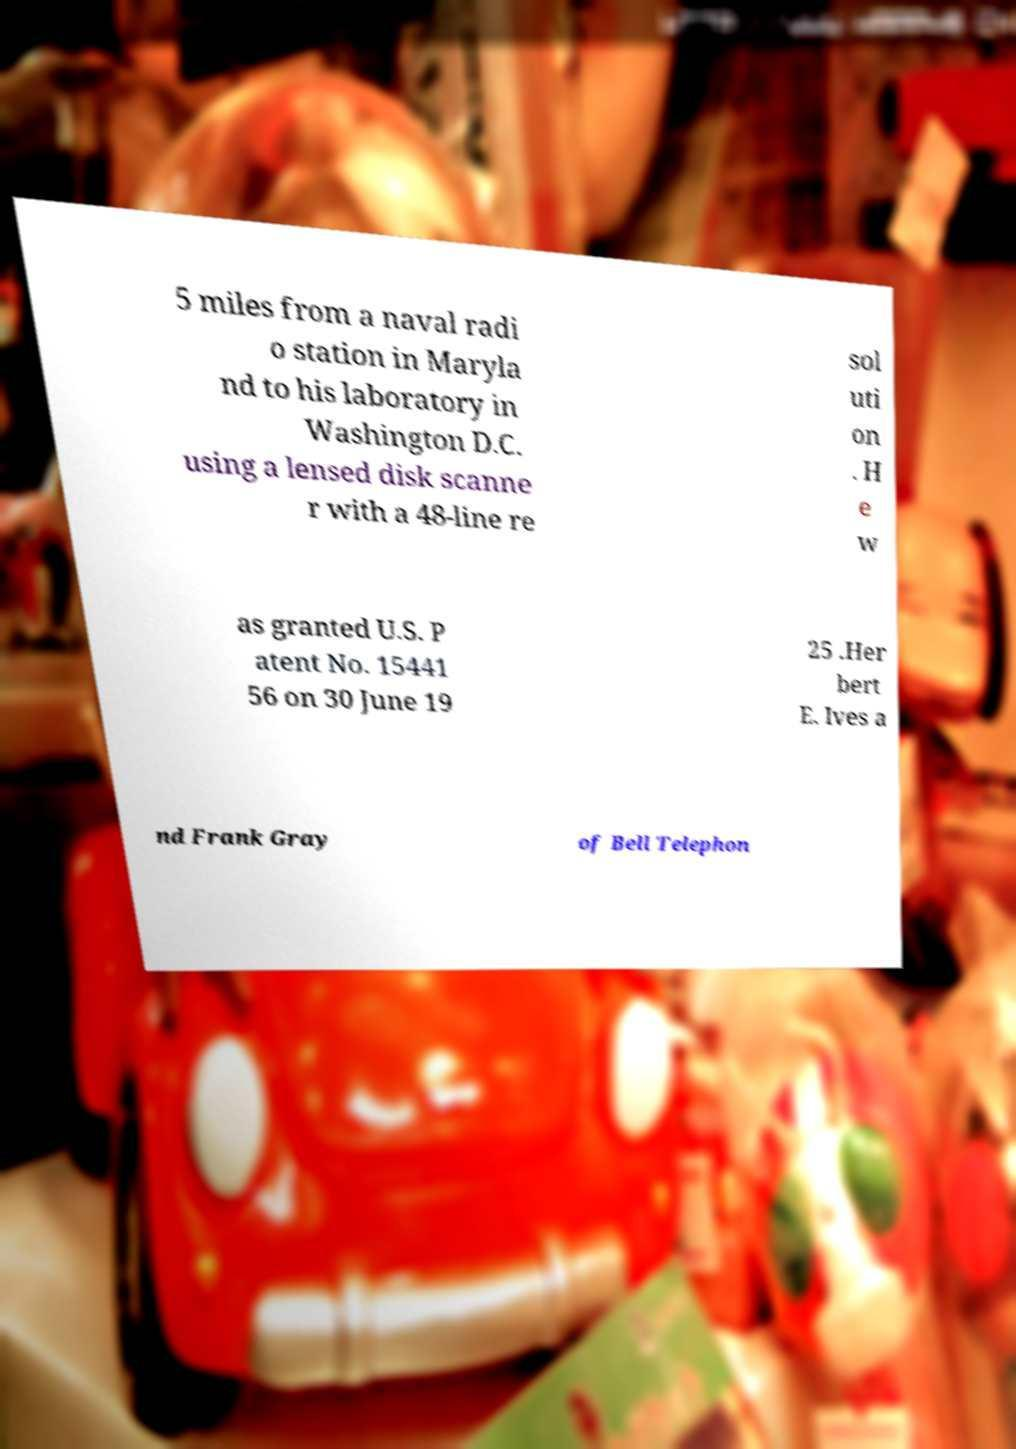Please identify and transcribe the text found in this image. 5 miles from a naval radi o station in Maryla nd to his laboratory in Washington D.C. using a lensed disk scanne r with a 48-line re sol uti on . H e w as granted U.S. P atent No. 15441 56 on 30 June 19 25 .Her bert E. Ives a nd Frank Gray of Bell Telephon 